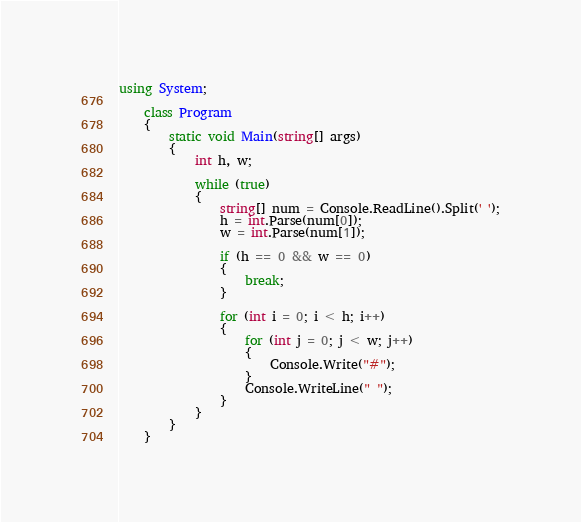<code> <loc_0><loc_0><loc_500><loc_500><_C#_>using System;

    class Program
    {
        static void Main(string[] args)
        {
            int h, w;

            while (true)
            {
                string[] num = Console.ReadLine().Split(' ');
                h = int.Parse(num[0]);
                w = int.Parse(num[1]);

                if (h == 0 && w == 0)
                {
                    break;
                }

                for (int i = 0; i < h; i++)
                {
                    for (int j = 0; j < w; j++)
                    {
                        Console.Write("#");
                    }
                    Console.WriteLine(" ");     
                }
            }
        }   
    }

</code> 